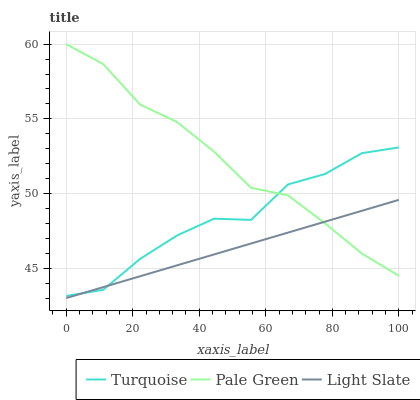Does Light Slate have the minimum area under the curve?
Answer yes or no. Yes. Does Pale Green have the maximum area under the curve?
Answer yes or no. Yes. Does Turquoise have the minimum area under the curve?
Answer yes or no. No. Does Turquoise have the maximum area under the curve?
Answer yes or no. No. Is Light Slate the smoothest?
Answer yes or no. Yes. Is Turquoise the roughest?
Answer yes or no. Yes. Is Pale Green the smoothest?
Answer yes or no. No. Is Pale Green the roughest?
Answer yes or no. No. Does Light Slate have the lowest value?
Answer yes or no. Yes. Does Turquoise have the lowest value?
Answer yes or no. No. Does Pale Green have the highest value?
Answer yes or no. Yes. Does Turquoise have the highest value?
Answer yes or no. No. Does Pale Green intersect Turquoise?
Answer yes or no. Yes. Is Pale Green less than Turquoise?
Answer yes or no. No. Is Pale Green greater than Turquoise?
Answer yes or no. No. 